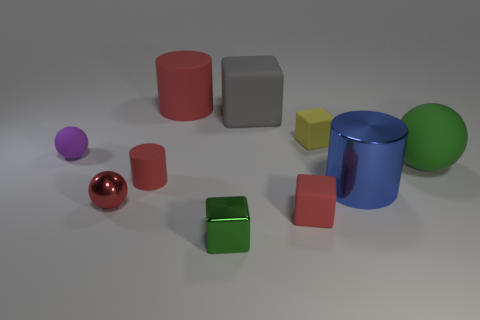Subtract all rubber spheres. How many spheres are left? 1 Subtract all cylinders. How many objects are left? 7 Subtract 1 spheres. How many spheres are left? 2 Subtract all green balls. How many balls are left? 2 Subtract 1 red balls. How many objects are left? 9 Subtract all gray cylinders. Subtract all purple balls. How many cylinders are left? 3 Subtract all red cubes. How many gray spheres are left? 0 Subtract all tiny purple metallic cylinders. Subtract all matte objects. How many objects are left? 3 Add 9 yellow cubes. How many yellow cubes are left? 10 Add 9 cyan matte cubes. How many cyan matte cubes exist? 9 